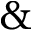<formula> <loc_0><loc_0><loc_500><loc_500>\&</formula> 